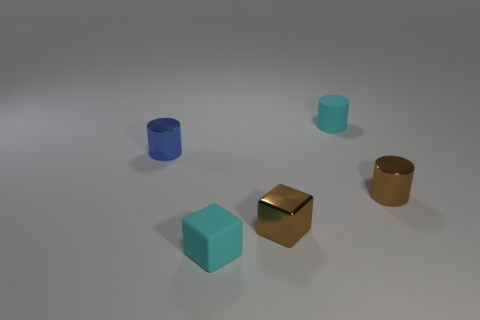What is the shape of the rubber object that is the same color as the tiny rubber cylinder?
Make the answer very short. Cube. How many matte cylinders are the same size as the blue object?
Offer a very short reply. 1. How many objects are both to the left of the brown metallic cube and on the right side of the tiny blue thing?
Provide a short and direct response. 1. There is a cylinder behind the blue metallic object; is it the same size as the blue cylinder?
Your answer should be compact. Yes. Is there a tiny object that has the same color as the rubber cylinder?
Your response must be concise. Yes. There is another cylinder that is made of the same material as the blue cylinder; what size is it?
Your answer should be compact. Small. Is the number of small brown metallic cylinders on the left side of the small cyan rubber cylinder greater than the number of brown metal objects in front of the tiny brown shiny cylinder?
Offer a terse response. No. What number of other things are the same material as the small cyan cube?
Provide a short and direct response. 1. Is the material of the tiny cyan thing that is behind the blue cylinder the same as the small cyan cube?
Your answer should be compact. Yes. What is the shape of the tiny blue shiny object?
Make the answer very short. Cylinder. 